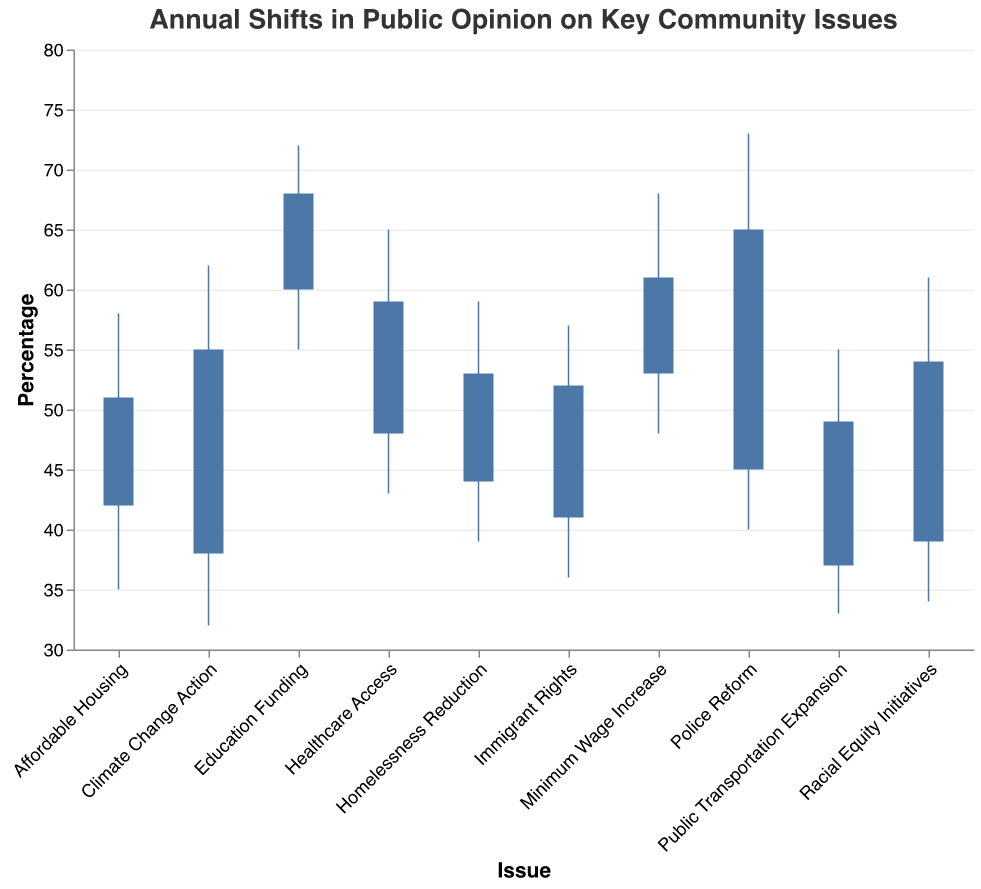What's the peak percentage for Police Reform? The peak percentage for Police Reform can be found on the y-axis at the highest vertical line on the figure associated with Police Reform.
Answer: 73 Which issue had the lowest trough percentage? To determine the issue with the lowest trough percentage, compare the trough values of all issues. The one with the smallest number is the lowest. Climate Change Action has the lowest trough value.
Answer: Climate Change Action How much did public opinion change from opening to closing for Healthcare Access? The change in public opinion from opening to closing for Healthcare Access is calculated by subtracting the opening percentage from the closing percentage. (59 - 48 = 11)
Answer: 11 Which issue has the highest closing percentage? The highest closing percentages for all issues on the y-axis show which issue has the highest one. Education Funding has the highest closing percentage of 68.
Answer: Education Funding What is the average peak percentage across all issues? Add up all the peak percentages and divide by the number of issues to find the average. (58 + 62 + 73 + 68 + 55 + 72 + 65 + 57 + 61 + 59) / 10 = 63
Answer: 63 Which issue saw the biggest decline from peak to trough percentages? Subtract the trough percentage from the peak percentage for each issue and compare the differences. The issue with the largest difference is Climate Change Action at 30 (62 - 32 = 30).
Answer: Climate Change Action Is Immigration Rights closing percentage higher than its opening percentage? Compare the opening and closing percentages for Immigration Rights. Since 52 (closing) is higher than 41 (opening), the answer is yes.
Answer: Yes Did any issue have its closing percentage equal to its peak percentage? For an issue to have its closing percentage equal to its peak percentage, the closing and peak values should be the same. None of the issues meet this criteria.
Answer: No How many issues saw their public opinion close higher than their opening percentage? Count the number of issues where the closing percentage is greater than the opening percentage. There are 8 issues where the closing percentage is higher than the opening.
Answer: 8 